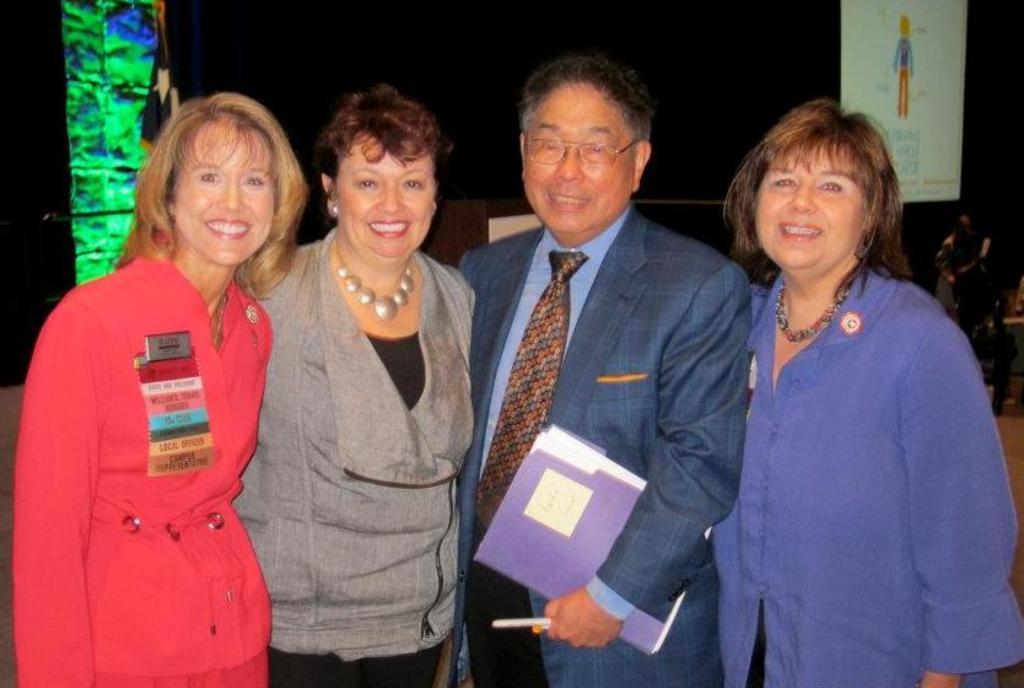Could you give a brief overview of what you see in this image? In the foreground of the picture there are three women and a man standing, they are smiling. In the background there are flag, banner, and a black curtain. On the right there is a person and chair. 